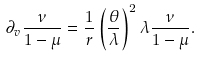<formula> <loc_0><loc_0><loc_500><loc_500>\partial _ { v } \frac { \nu } { 1 - \mu } = \frac { 1 } r \left ( \frac { \theta } { \lambda } \right ) ^ { 2 } \lambda \frac { \nu } { 1 - \mu } .</formula> 